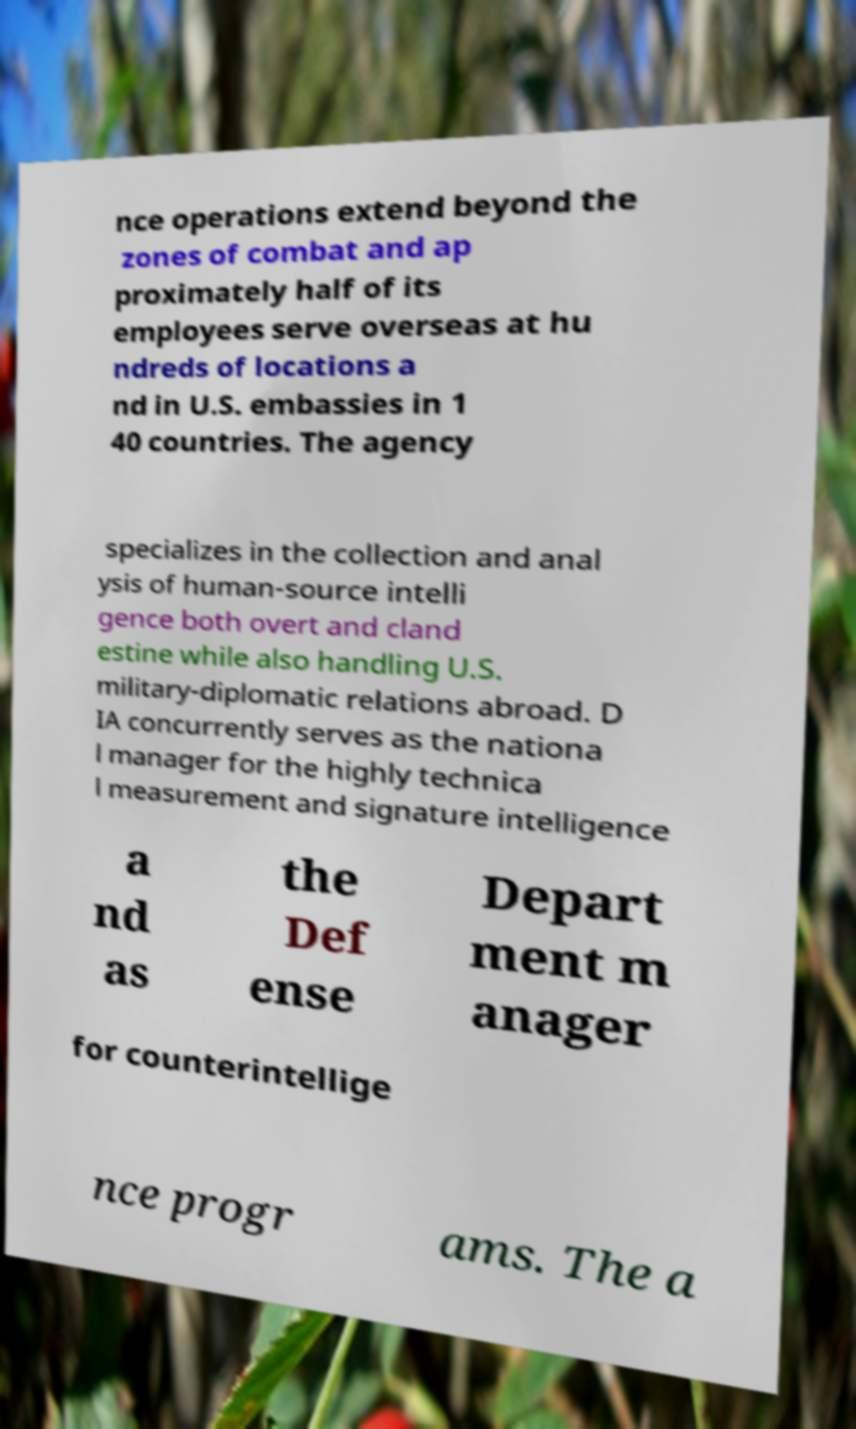For documentation purposes, I need the text within this image transcribed. Could you provide that? nce operations extend beyond the zones of combat and ap proximately half of its employees serve overseas at hu ndreds of locations a nd in U.S. embassies in 1 40 countries. The agency specializes in the collection and anal ysis of human-source intelli gence both overt and cland estine while also handling U.S. military-diplomatic relations abroad. D IA concurrently serves as the nationa l manager for the highly technica l measurement and signature intelligence a nd as the Def ense Depart ment m anager for counterintellige nce progr ams. The a 